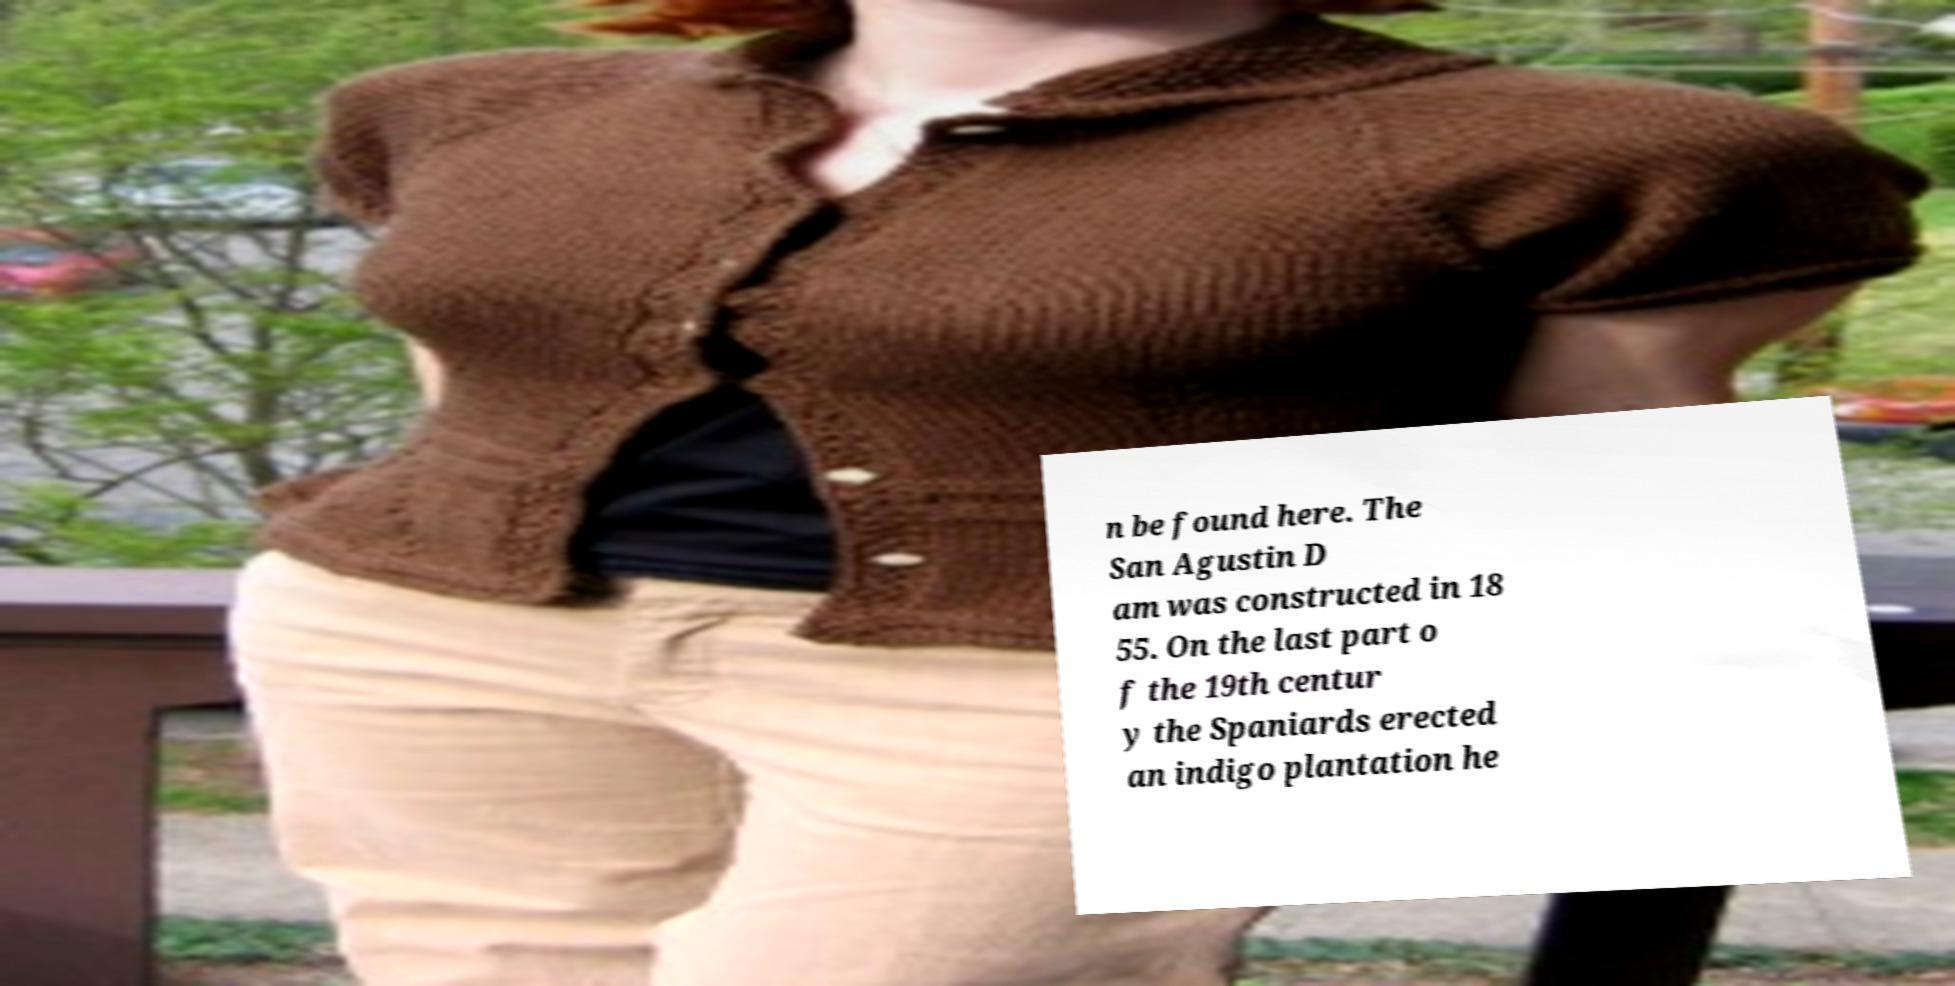Can you read and provide the text displayed in the image?This photo seems to have some interesting text. Can you extract and type it out for me? n be found here. The San Agustin D am was constructed in 18 55. On the last part o f the 19th centur y the Spaniards erected an indigo plantation he 